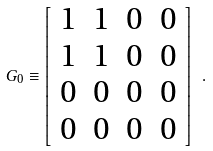Convert formula to latex. <formula><loc_0><loc_0><loc_500><loc_500>G _ { 0 } \equiv \left [ \begin{array} { c c c c } 1 & 1 & 0 & 0 \\ 1 & 1 & 0 & 0 \\ 0 & 0 & 0 & 0 \\ 0 & 0 & 0 & 0 \\ \end{array} \right ] \ .</formula> 